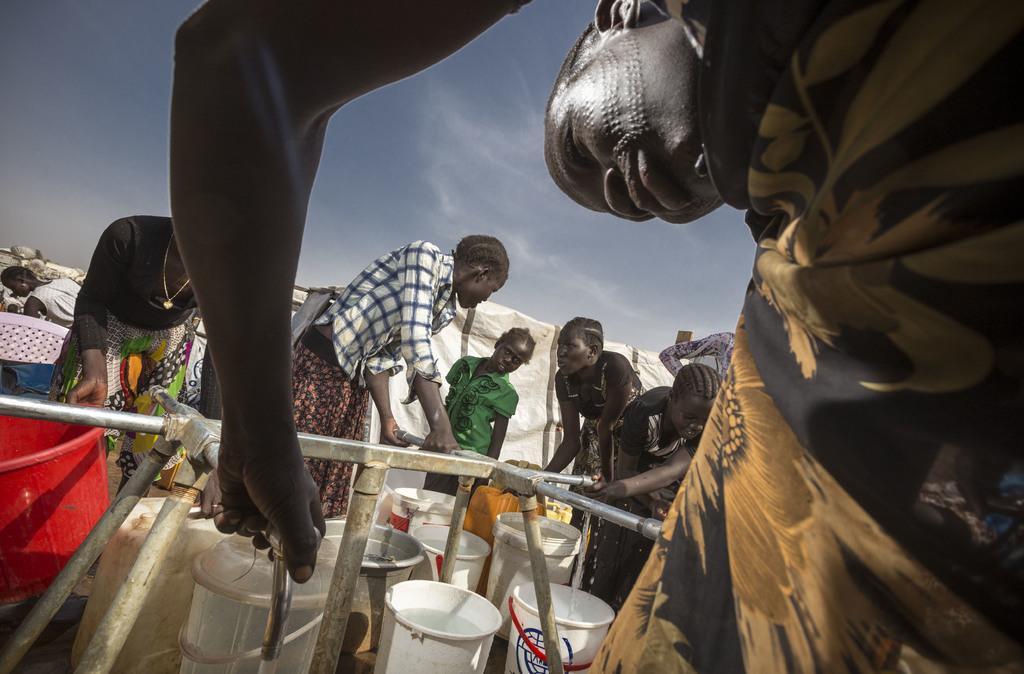Describe this image in one or two sentences. In this picture we can see a group of people, buckets, taps, pipes and some objects and in the background we can see the sky. 